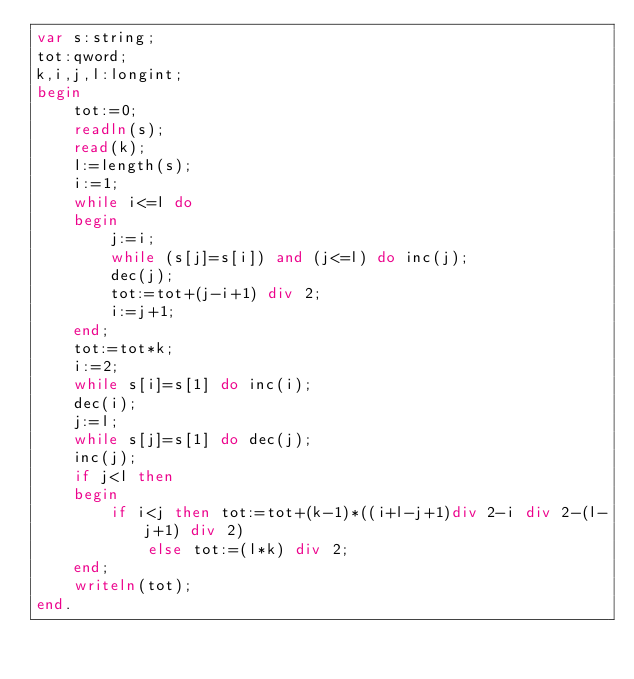Convert code to text. <code><loc_0><loc_0><loc_500><loc_500><_Pascal_>var s:string;
tot:qword;
k,i,j,l:longint;
begin 
	tot:=0;
	readln(s);
	read(k);
	l:=length(s);
	i:=1;
	while i<=l do 
	begin 
		j:=i;
		while (s[j]=s[i]) and (j<=l) do inc(j);
		dec(j);
		tot:=tot+(j-i+1) div 2;
		i:=j+1;
	end;
	tot:=tot*k;
	i:=2;
	while s[i]=s[1] do inc(i);
	dec(i);
	j:=l;
	while s[j]=s[1] do dec(j);
	inc(j);
	if j<l then 
	begin 
		if i<j then tot:=tot+(k-1)*((i+l-j+1)div 2-i div 2-(l-j+1) div 2)
			else tot:=(l*k) div 2;
	end;
	writeln(tot);
end.</code> 